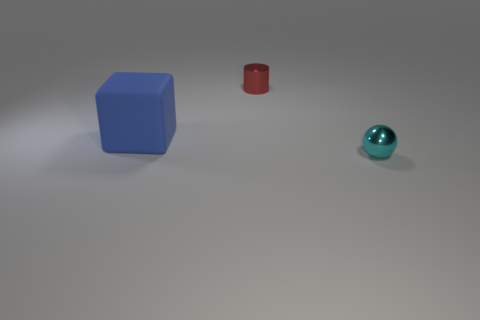Add 2 large brown cubes. How many objects exist? 5 Subtract 1 blocks. How many blocks are left? 0 Subtract all balls. How many objects are left? 2 Subtract 0 green cubes. How many objects are left? 3 Subtract all green blocks. Subtract all cyan balls. How many blocks are left? 1 Subtract all green balls. How many purple cylinders are left? 0 Subtract all tiny red objects. Subtract all tiny metal cylinders. How many objects are left? 1 Add 3 cyan spheres. How many cyan spheres are left? 4 Add 2 large brown rubber objects. How many large brown rubber objects exist? 2 